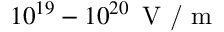<formula> <loc_0><loc_0><loc_500><loc_500>1 0 ^ { 1 9 } - 1 0 ^ { 2 0 } \, V / m</formula> 